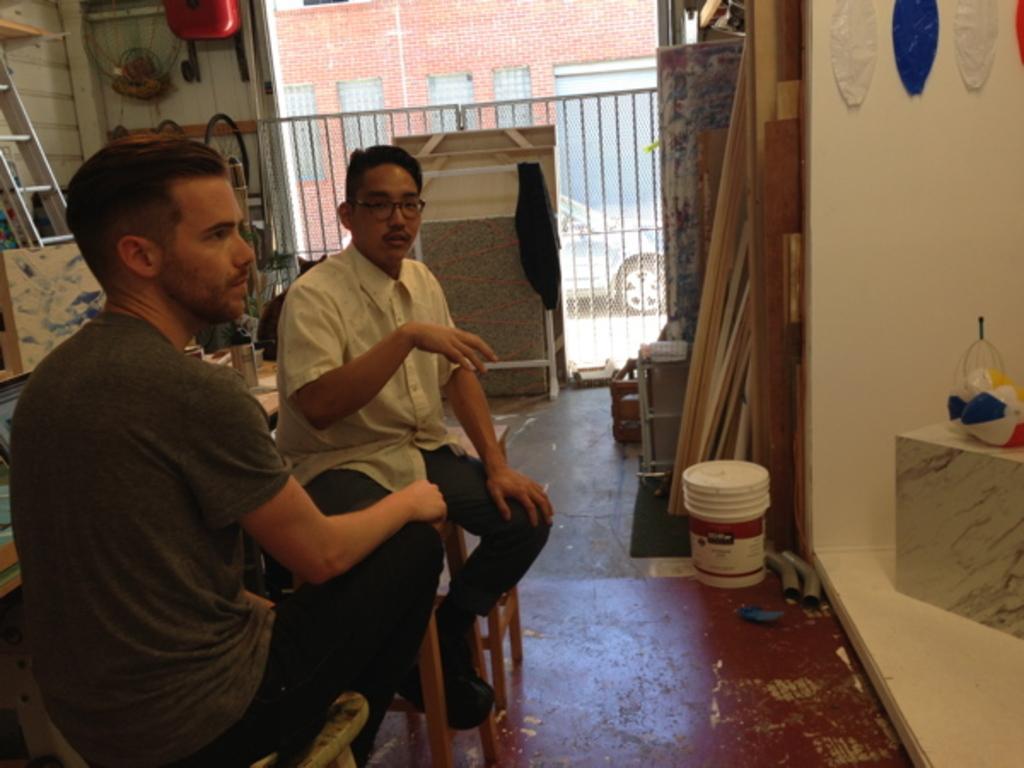Could you give a brief overview of what you see in this image? In this image we can see two people sitting. In the center there is a bucket. On the right we can see a stool and there are things placed on the stool. In the background there are wooden planks, table, ladder and some things and there is a building. 